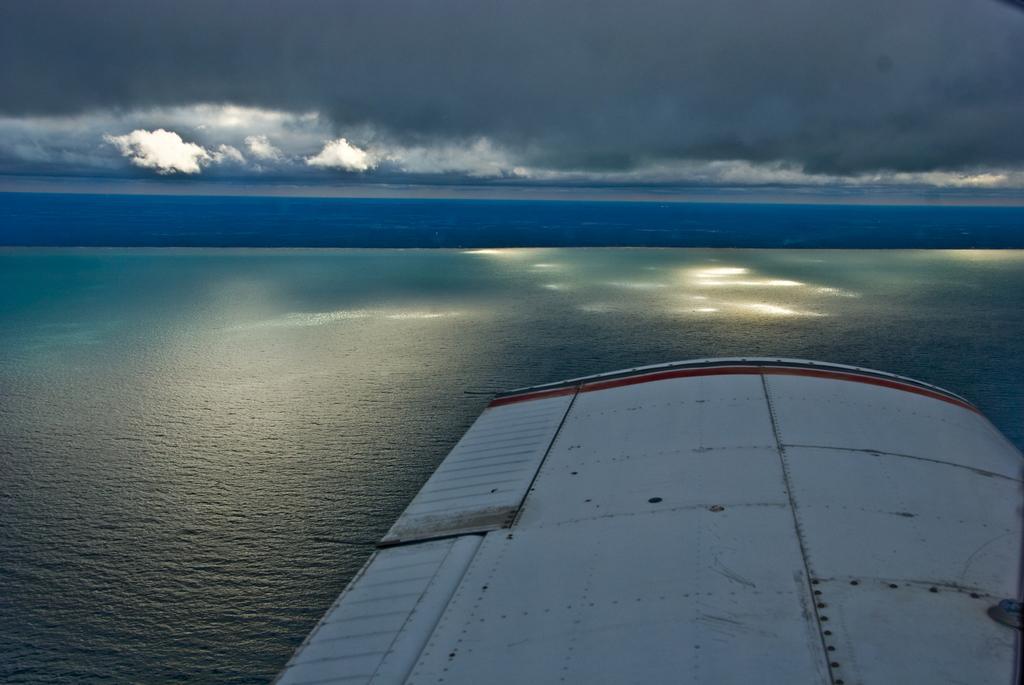Please provide a concise description of this image. In this picture there is water at the bottom side of the image and there is sky at the top side of the image, there is roof in the bottom right side of the image. 